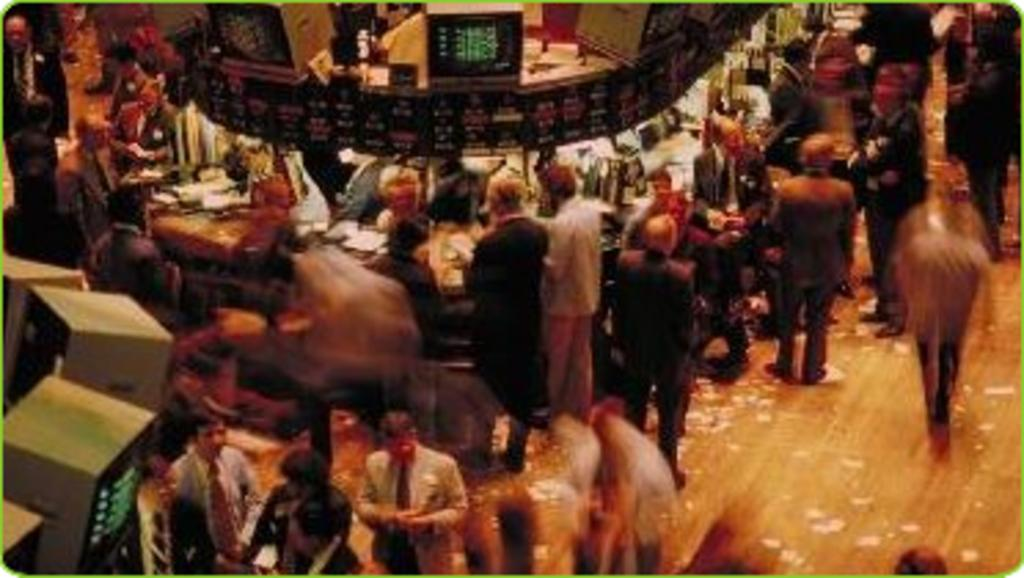What type of establishment is depicted in the image? The image shows a bank. Can you describe the actions of the people in the image? Some people are standing near a desk, and some people are talking to each other. What type of prose is being recited by the people in the image? There is no indication in the image that people are reciting any prose. What religious beliefs are being discussed by the people in the image? There is no indication in the image that people are discussing any religious beliefs. 